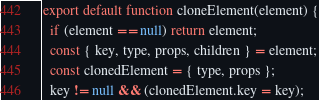Convert code to text. <code><loc_0><loc_0><loc_500><loc_500><_JavaScript_>export default function cloneElement(element) {
  if (element == null) return element;
  const { key, type, props, children } = element;
  const clonedElement = { type, props };
  key != null && (clonedElement.key = key);</code> 